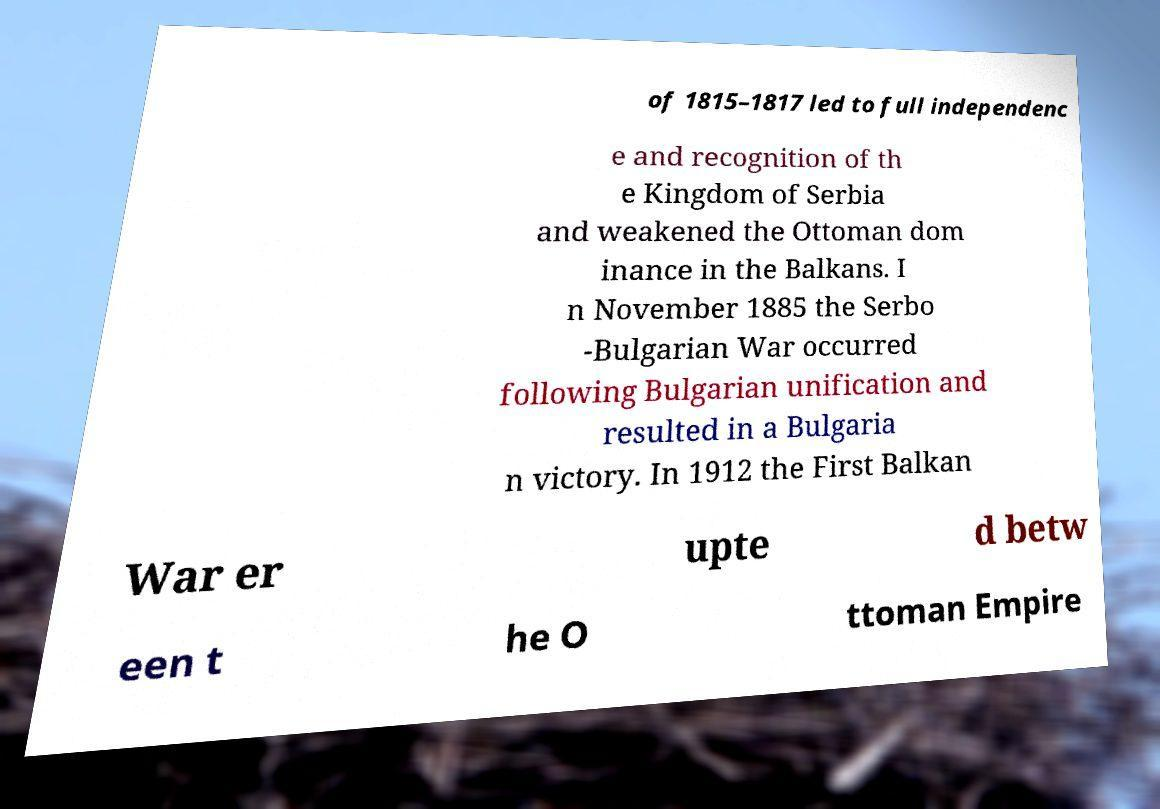I need the written content from this picture converted into text. Can you do that? of 1815–1817 led to full independenc e and recognition of th e Kingdom of Serbia and weakened the Ottoman dom inance in the Balkans. I n November 1885 the Serbo -Bulgarian War occurred following Bulgarian unification and resulted in a Bulgaria n victory. In 1912 the First Balkan War er upte d betw een t he O ttoman Empire 